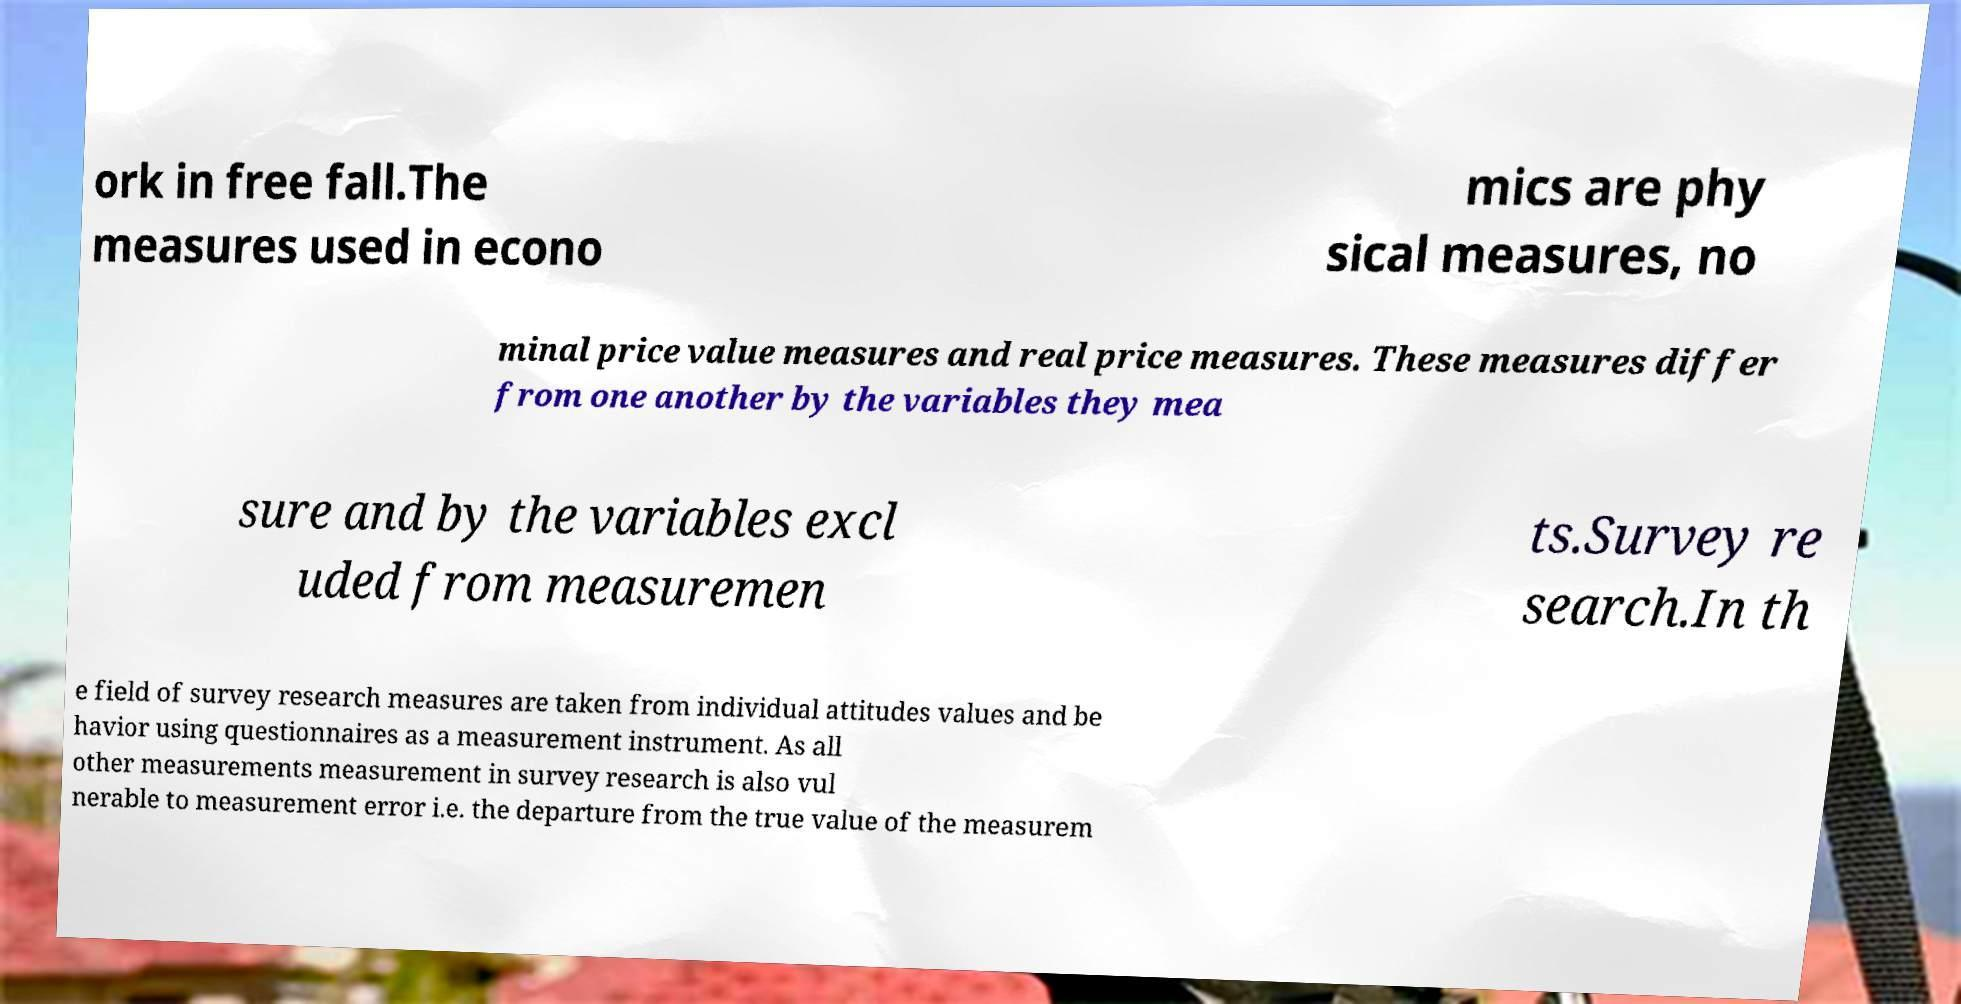There's text embedded in this image that I need extracted. Can you transcribe it verbatim? ork in free fall.The measures used in econo mics are phy sical measures, no minal price value measures and real price measures. These measures differ from one another by the variables they mea sure and by the variables excl uded from measuremen ts.Survey re search.In th e field of survey research measures are taken from individual attitudes values and be havior using questionnaires as a measurement instrument. As all other measurements measurement in survey research is also vul nerable to measurement error i.e. the departure from the true value of the measurem 